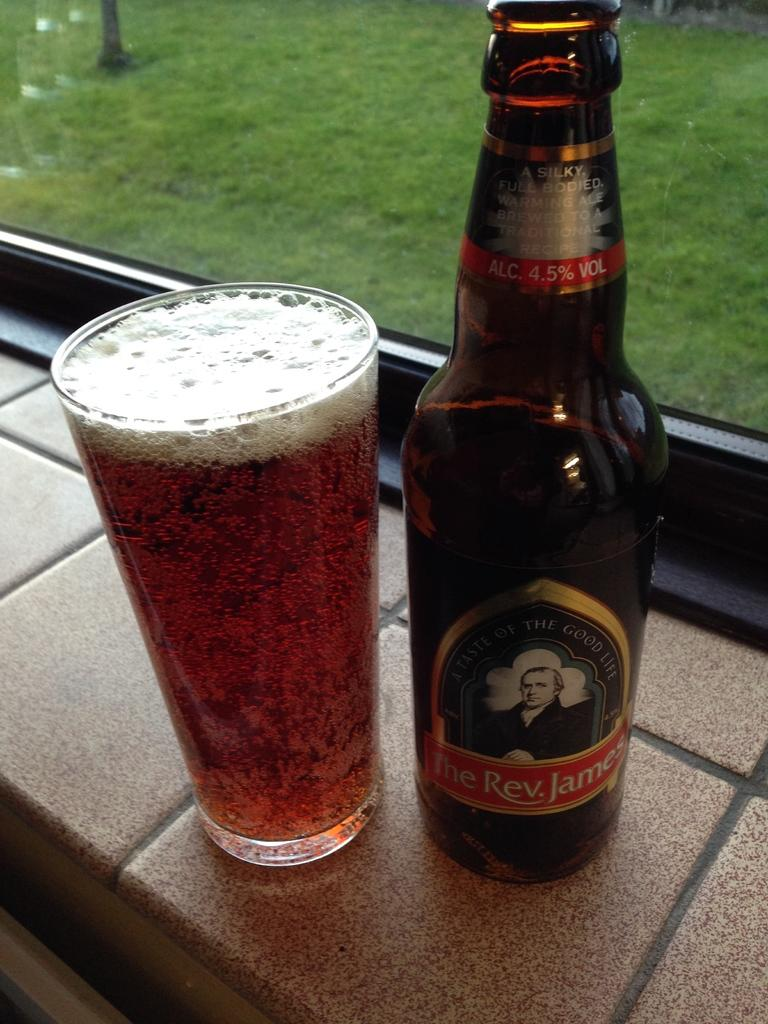What type of drink is in the glass that is visible in the image? There is a glass of beer in the image. What other beer-related item is present in the image? There is a beer bottle in the image. Where are the glass and bottle placed in the image? Both the glass and bottle are placed on a wall. What can be seen through the window in the background of the image? There is a transparent glass window in the background, and grass is visible through it. What is the purpose of the anger in the image? There is no anger present in the image; it is a scene featuring a glass of beer, a beer bottle, and a window with grass visible through it. 